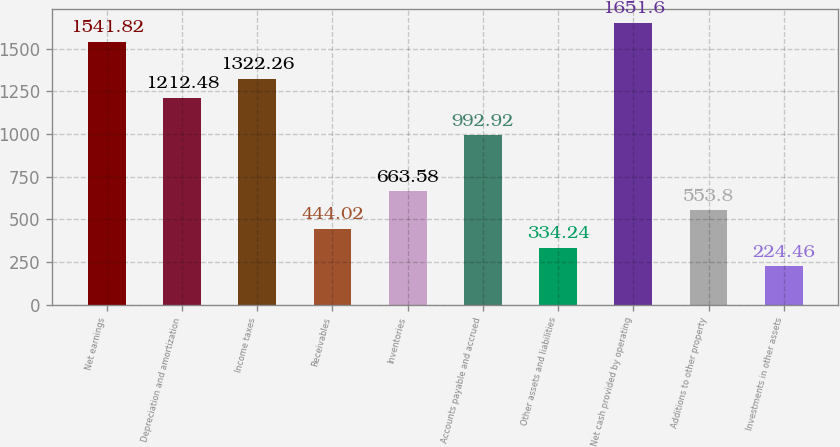Convert chart to OTSL. <chart><loc_0><loc_0><loc_500><loc_500><bar_chart><fcel>Net earnings<fcel>Depreciation and amortization<fcel>Income taxes<fcel>Receivables<fcel>Inventories<fcel>Accounts payable and accrued<fcel>Other assets and liabilities<fcel>Net cash provided by operating<fcel>Additions to other property<fcel>Investments in other assets<nl><fcel>1541.82<fcel>1212.48<fcel>1322.26<fcel>444.02<fcel>663.58<fcel>992.92<fcel>334.24<fcel>1651.6<fcel>553.8<fcel>224.46<nl></chart> 